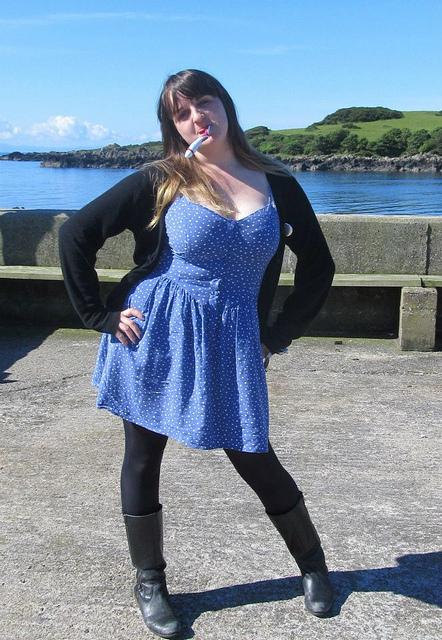To which direction of the woman is the sun located? Please explain your reasoning. left. Because her reflection is on the right side. 